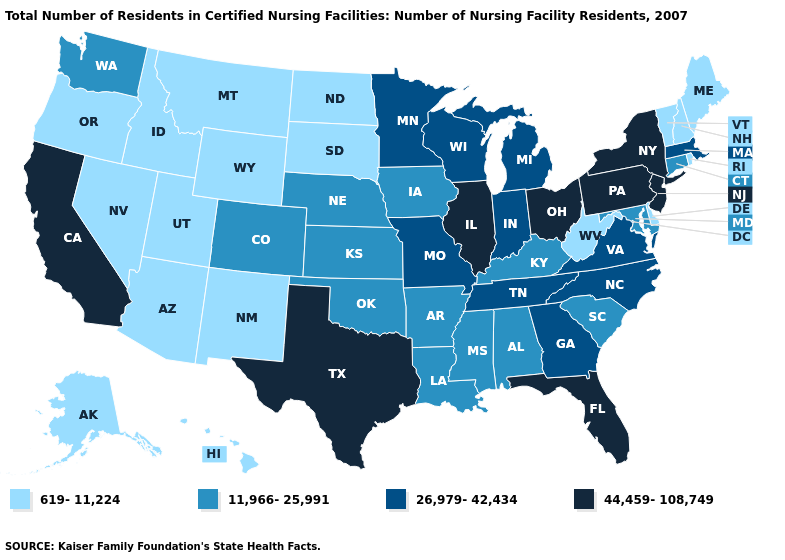Does the map have missing data?
Give a very brief answer. No. What is the value of Wisconsin?
Write a very short answer. 26,979-42,434. What is the value of Ohio?
Give a very brief answer. 44,459-108,749. Name the states that have a value in the range 44,459-108,749?
Give a very brief answer. California, Florida, Illinois, New Jersey, New York, Ohio, Pennsylvania, Texas. Name the states that have a value in the range 44,459-108,749?
Short answer required. California, Florida, Illinois, New Jersey, New York, Ohio, Pennsylvania, Texas. What is the value of New Hampshire?
Keep it brief. 619-11,224. Name the states that have a value in the range 619-11,224?
Give a very brief answer. Alaska, Arizona, Delaware, Hawaii, Idaho, Maine, Montana, Nevada, New Hampshire, New Mexico, North Dakota, Oregon, Rhode Island, South Dakota, Utah, Vermont, West Virginia, Wyoming. Is the legend a continuous bar?
Give a very brief answer. No. Does Minnesota have a higher value than Arizona?
Write a very short answer. Yes. Which states have the highest value in the USA?
Give a very brief answer. California, Florida, Illinois, New Jersey, New York, Ohio, Pennsylvania, Texas. What is the value of Delaware?
Be succinct. 619-11,224. Name the states that have a value in the range 619-11,224?
Be succinct. Alaska, Arizona, Delaware, Hawaii, Idaho, Maine, Montana, Nevada, New Hampshire, New Mexico, North Dakota, Oregon, Rhode Island, South Dakota, Utah, Vermont, West Virginia, Wyoming. Does Alaska have the highest value in the USA?
Answer briefly. No. Does Washington have a lower value than Illinois?
Answer briefly. Yes. What is the value of North Carolina?
Answer briefly. 26,979-42,434. 